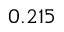<formula> <loc_0><loc_0><loc_500><loc_500>0 . 2 1 5</formula> 